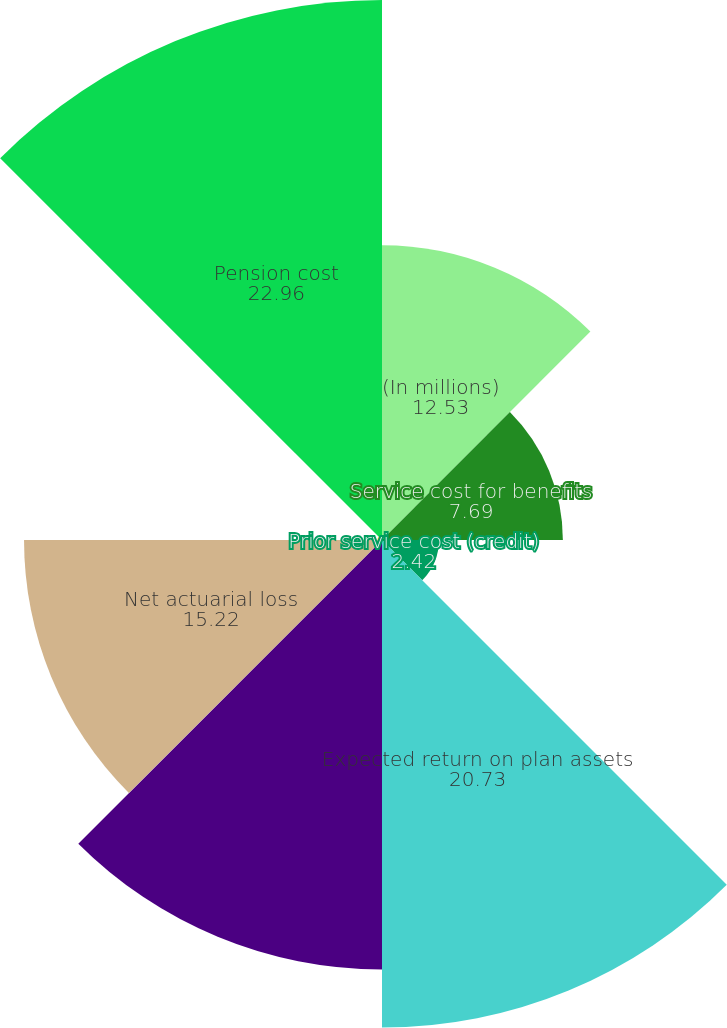Convert chart to OTSL. <chart><loc_0><loc_0><loc_500><loc_500><pie_chart><fcel>(In millions)<fcel>Service cost for benefits<fcel>Prior service cost (credit)<fcel>Expected return on plan assets<fcel>Interest cost on benefit<fcel>Net actuarial loss<fcel>Curtailment loss (gain)<fcel>Pension cost<nl><fcel>12.53%<fcel>7.69%<fcel>2.42%<fcel>20.73%<fcel>18.26%<fcel>15.22%<fcel>0.19%<fcel>22.96%<nl></chart> 